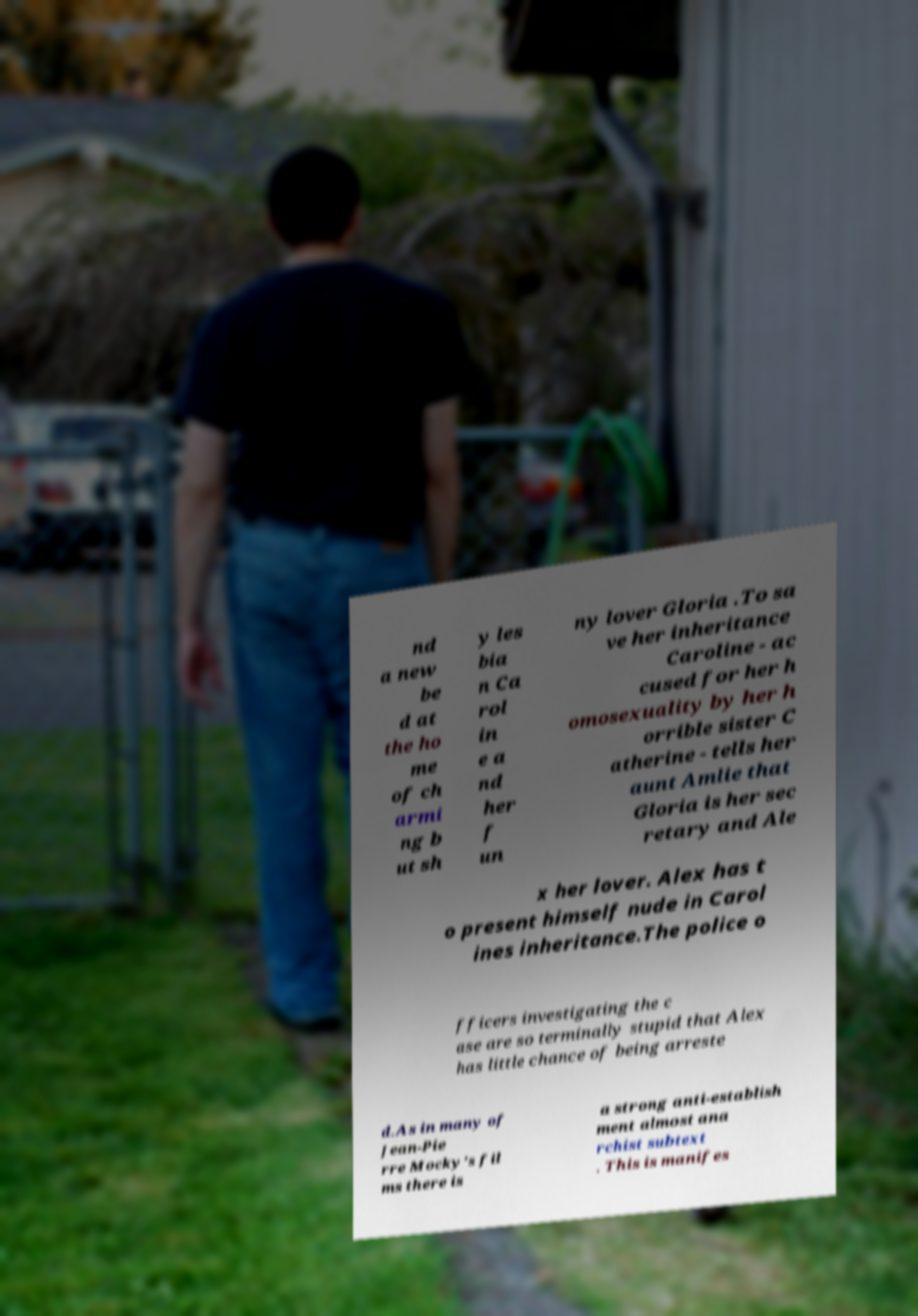There's text embedded in this image that I need extracted. Can you transcribe it verbatim? nd a new be d at the ho me of ch armi ng b ut sh y les bia n Ca rol in e a nd her f un ny lover Gloria .To sa ve her inheritance Caroline - ac cused for her h omosexuality by her h orrible sister C atherine - tells her aunt Amlie that Gloria is her sec retary and Ale x her lover. Alex has t o present himself nude in Carol ines inheritance.The police o fficers investigating the c ase are so terminally stupid that Alex has little chance of being arreste d.As in many of Jean-Pie rre Mocky's fil ms there is a strong anti-establish ment almost ana rchist subtext . This is manifes 